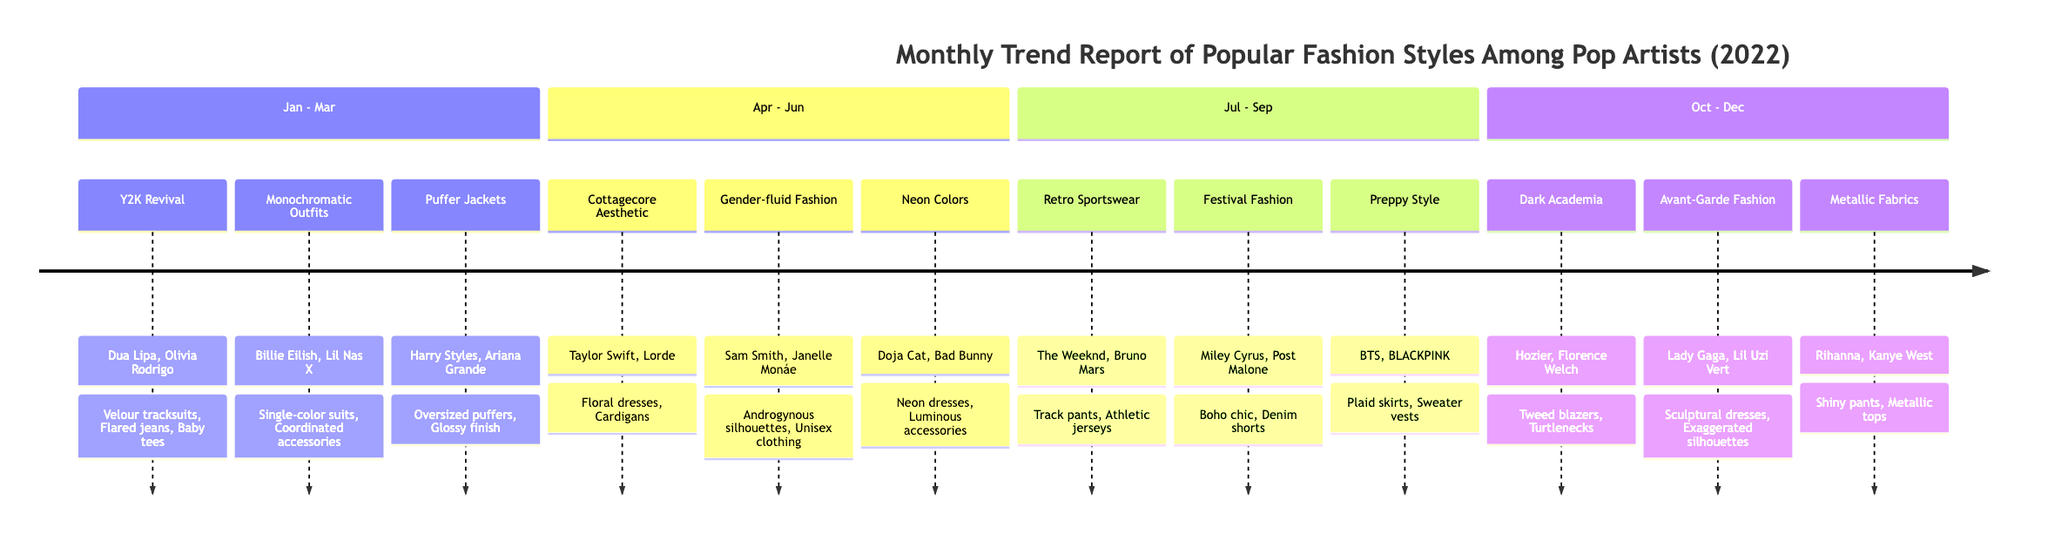What's the trend for January 2022? The trend for January 2022 is identified in the first section of the timeline, labeled clearly as the trend for that month, leading us to "Y2K Revival."
Answer: Y2K Revival Who are the key influencers for April 2022? To find the key influencers for April 2022, we look at the section for that month in the timeline, which lists "Taylor Swift" and "Lorde" as the key influencers.
Answer: Taylor Swift, Lorde How many fashion elements are listed for June 2022? For June 2022, we examine the section labeled for that month which provides three fashion elements: "Neon dresses," "Luminous accessories," and "Bright footwear," making the total three elements.
Answer: 3 What was the trend during the summer months of July and August? We check the timeline for both July and August. July features "Retro Sportswear," while August showcases "Festival Fashion," indicating both trends were prevalent during the summer.
Answer: Retro Sportswear, Festival Fashion Which month featured "Avant-Garde Fashion" and who were its key influencers? The timeline specifically indicates that "Avant-Garde Fashion" was the trend for November 2022, with "Lady Gaga" and "Lil Uzi Vert" listed as key influencers.
Answer: November 2022, Lady Gaga, Lil Uzi Vert What is the overarching theme of fashion trends from January to March 2022? Analyzing the trends from January to March, we identify themes of nostalgia and comfort starting with "Y2K Revival," followed by "Monochromatic Outfits" and "Puffer Jackets," suggesting a trend towards both retro styles and cozy apparel.
Answer: Nostalgia and Comfort How do the fashion elements of September 2022 relate to school fashion? In September 2022, the fashion elements include "Plaid skirts," "Sweater vests," and "Loafers," which are typical components of preppy attire often associated with school or academic environments, exemplifying the preppy style theme for that month.
Answer: Preppy Style What was the most prominent fashion trend of the last quarter of 2022? By examining the last quarter, we find that the trend for December 2022 was "Metallic Fabrics," thus marking it as the most prominent trend for that period.
Answer: Metallic Fabrics Which fashion elements featured in the trend of Gender-fluid Fashion? The timeline lists "Androgynous silhouettes," "Unisex clothing," and "Mixed fabrics" as the fashion elements corresponding to the trend of Gender-fluid Fashion in May 2022.
Answer: Androgynous silhouettes, Unisex clothing, Mixed fabrics 